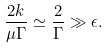<formula> <loc_0><loc_0><loc_500><loc_500>\frac { 2 k } { \mu \Gamma } \simeq \frac { 2 } { \Gamma } \gg \epsilon .</formula> 